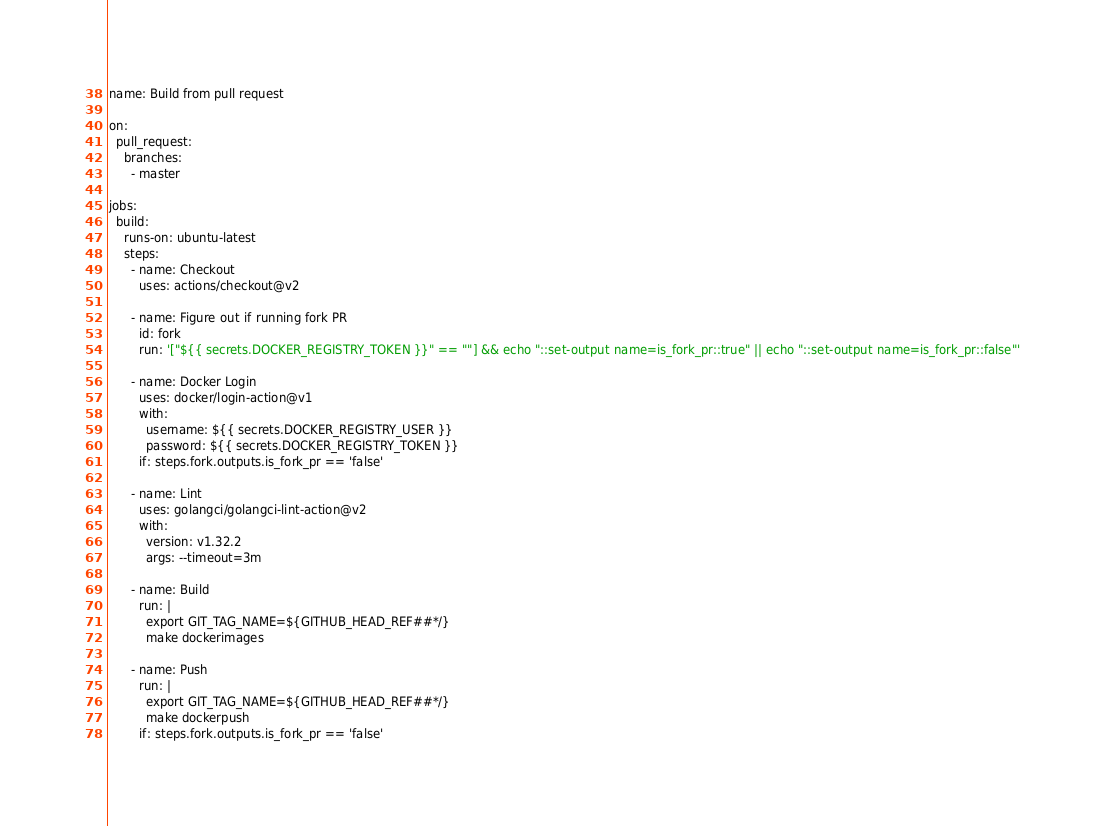Convert code to text. <code><loc_0><loc_0><loc_500><loc_500><_YAML_>name: Build from pull request

on:
  pull_request:
    branches:
      - master

jobs:
  build:
    runs-on: ubuntu-latest
    steps:
      - name: Checkout
        uses: actions/checkout@v2

      - name: Figure out if running fork PR
        id: fork
        run: '["${{ secrets.DOCKER_REGISTRY_TOKEN }}" == ""] && echo "::set-output name=is_fork_pr::true" || echo "::set-output name=is_fork_pr::false"'

      - name: Docker Login
        uses: docker/login-action@v1
        with:
          username: ${{ secrets.DOCKER_REGISTRY_USER }}
          password: ${{ secrets.DOCKER_REGISTRY_TOKEN }}
        if: steps.fork.outputs.is_fork_pr == 'false'

      - name: Lint
        uses: golangci/golangci-lint-action@v2
        with:
          version: v1.32.2
          args: --timeout=3m

      - name: Build
        run: |
          export GIT_TAG_NAME=${GITHUB_HEAD_REF##*/}
          make dockerimages

      - name: Push
        run: |
          export GIT_TAG_NAME=${GITHUB_HEAD_REF##*/}
          make dockerpush
        if: steps.fork.outputs.is_fork_pr == 'false'
</code> 